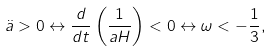<formula> <loc_0><loc_0><loc_500><loc_500>\ddot { a } > 0 \leftrightarrow \frac { d } { d t } \left ( \frac { 1 } { a H } \right ) < 0 \leftrightarrow \omega < - \frac { 1 } { 3 } ,</formula> 